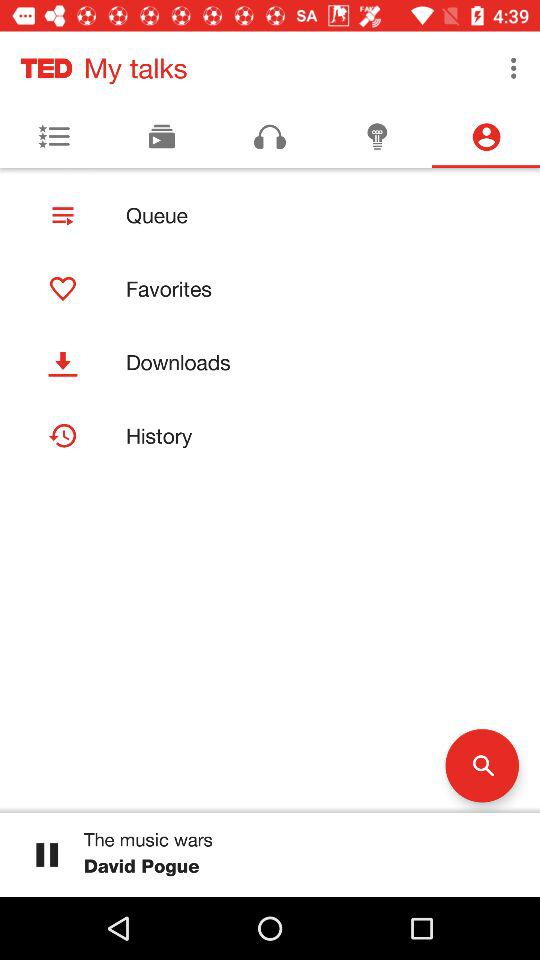Which music is playing? The music that is playing is "The music wars". 